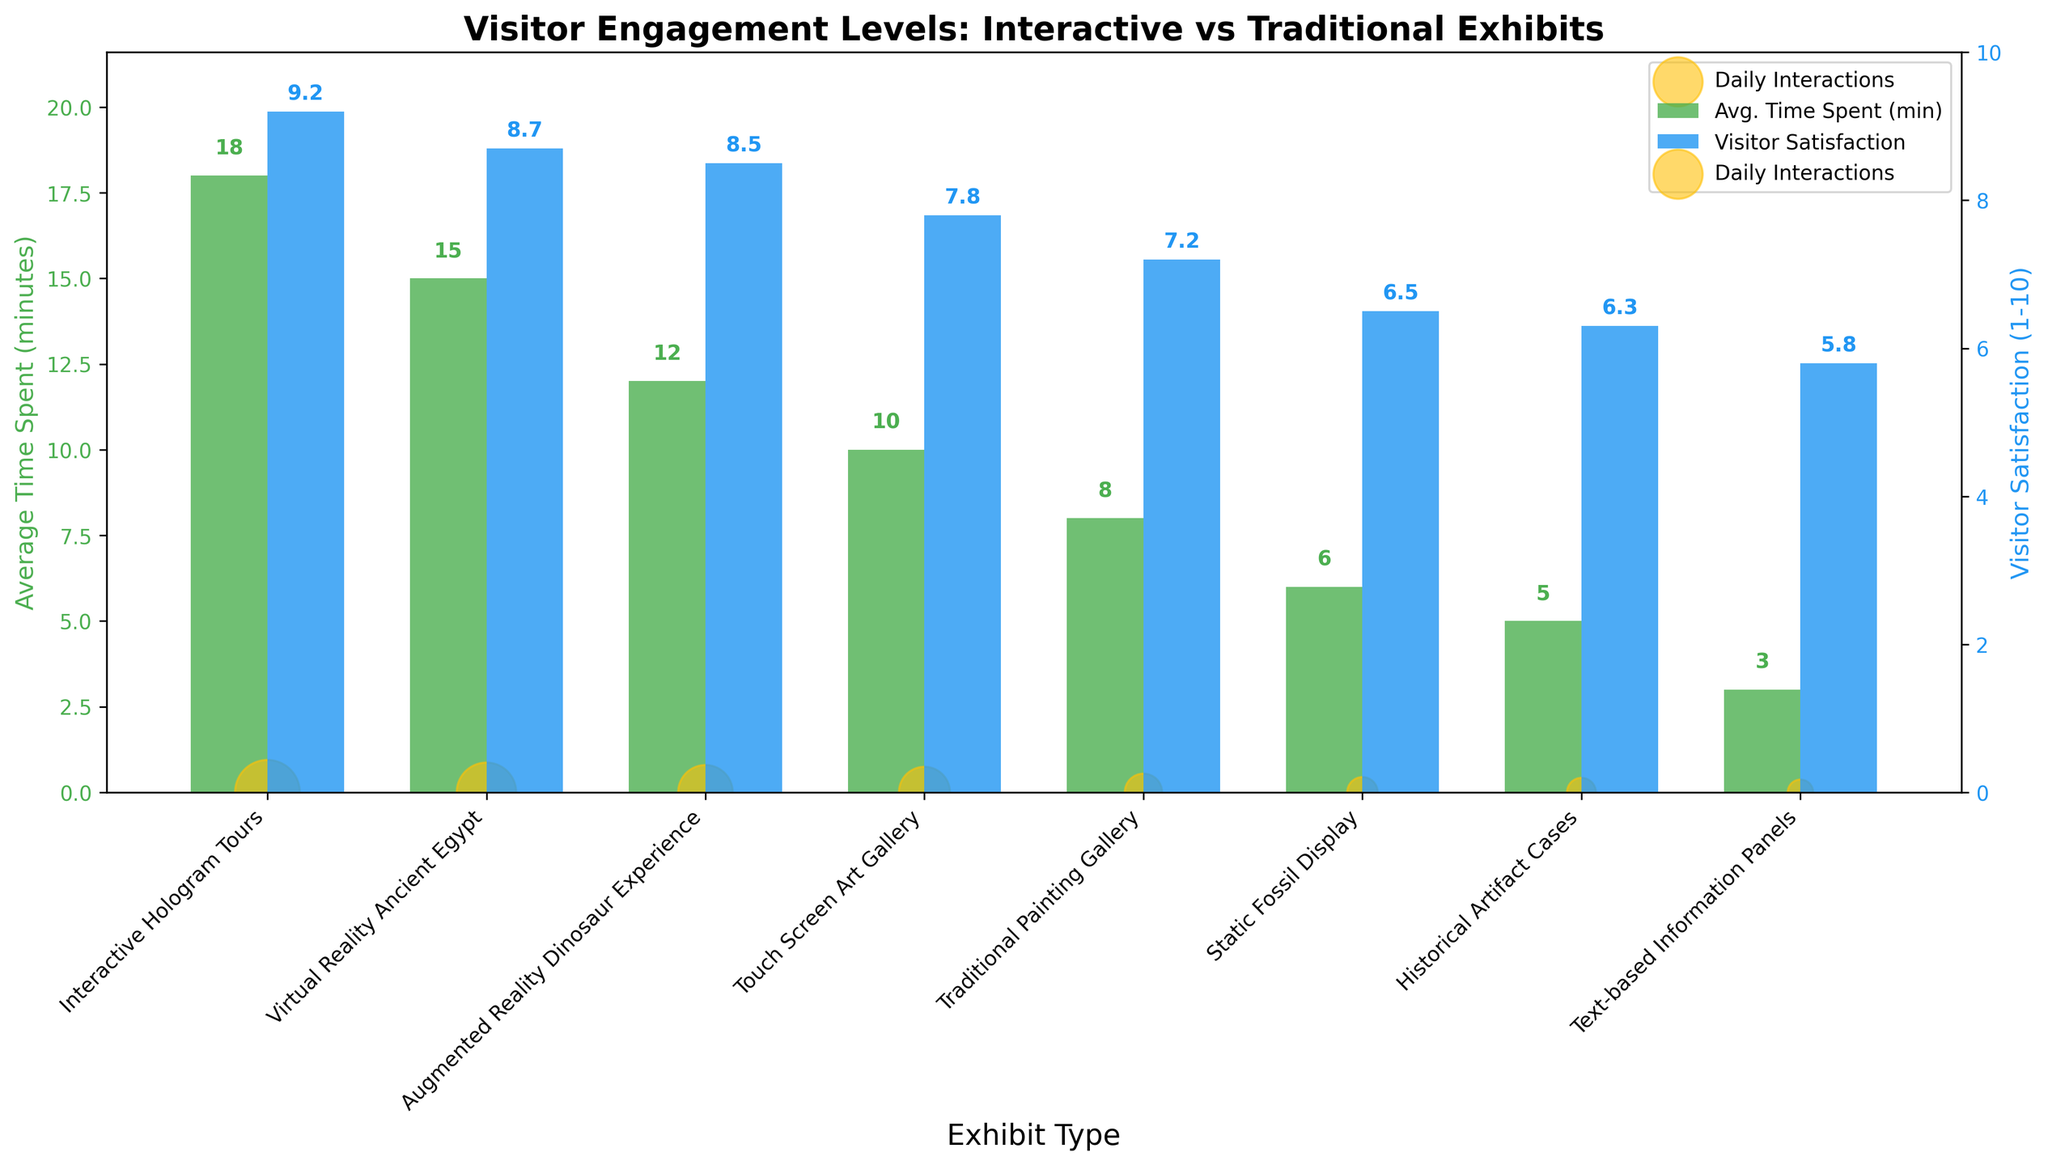What exhibit type has the highest average visitor satisfaction score? The bar chart shows the average visitor satisfaction scores with different colors. The tallest blue bar represents the highest satisfaction score. The "Interactive Hologram Tours" has the highest satisfaction score.
Answer: Interactive Hologram Tours How does the average time spent at "Text-based Information Panels" compare to "Interactive Hologram Tours"? The bar representing the average time spent at "Text-based Information Panels" is much shorter than the bar for "Interactive Hologram Tours". "Text-based Information Panels" show 3 minutes, while "Interactive Hologram Tours" show 18 minutes.
Answer: 3 minutes vs. 18 minutes Which exhibit has the lowest daily interactions? The scatter points represent daily interactions. The smallest scatter point corresponds to the "Text-based Information Panels" with 70 daily interactions.
Answer: Text-based Information Panels What is the combined average time spent for both the "Virtual Reality Ancient Egypt" and the "Touch Screen Art Gallery"? The average time spent on "Virtual Reality Ancient Egypt" is 15 minutes, and for "Touch Screen Art Gallery", it is 10 minutes. Adding them together gives 15 + 10 = 25 minutes.
Answer: 25 minutes Is the visitor satisfaction for "Augmented Reality Dinosaur Experience" greater than "Static Fossil Display"? By comparing the blue bars representing satisfaction, "Augmented Reality Dinosaur Experience" has a satisfaction score of 8.5, while "Static Fossil Display" has 6.5. Thus, the satisfaction is greater for the "Augmented Reality Dinosaur Experience".
Answer: Yes Which exhibit type combines the highest levels of average time spent and visitor satisfaction? Looking at both green and blue bars, "Interactive Hologram Tours" have both the highest average time spent (18 minutes) and the highest satisfaction (9.2).
Answer: Interactive Hologram Tours Determine the difference in visitor satisfaction between "Traditional Painting Gallery" and "Historical Artifact Cases". "Traditional Painting Gallery" has a satisfaction score of 7.2, and "Historical Artifact Cases" have 6.3. The difference is 7.2 - 6.3 = 0.9.
Answer: 0.9 Which exhibits have an average time spent above 10 minutes? The green bars for "Interactive Hologram Tours" (18), "Virtual Reality Ancient Egypt" (15), and "Augmented Reality Dinosaur Experience" (12) all are above the 10-minute mark.
Answer: Interactive Hologram Tours, Virtual Reality Ancient Egypt, Augmented Reality Dinosaur Experience What is the average visitor satisfaction score for all exhibit types combined? Adding the satisfaction scores: 9.2 + 8.7 + 8.5 + 7.8 + 7.2 + 6.5 + 6.3 + 5.8, which equals 60. So, 60 divided by 8 exhibit types gives an average of 60/8 = 7.5.
Answer: 7.5 How does the satisfaction for "Touch Screen Art Gallery" compare to the "Traditional Painting Gallery"? The satisfaction for "Touch Screen Art Gallery" is shown as 7.8, while "Traditional Painting Gallery" has a satisfaction of 7.2. So, "Touch Screen Art Gallery" has higher satisfaction.
Answer: Higher 